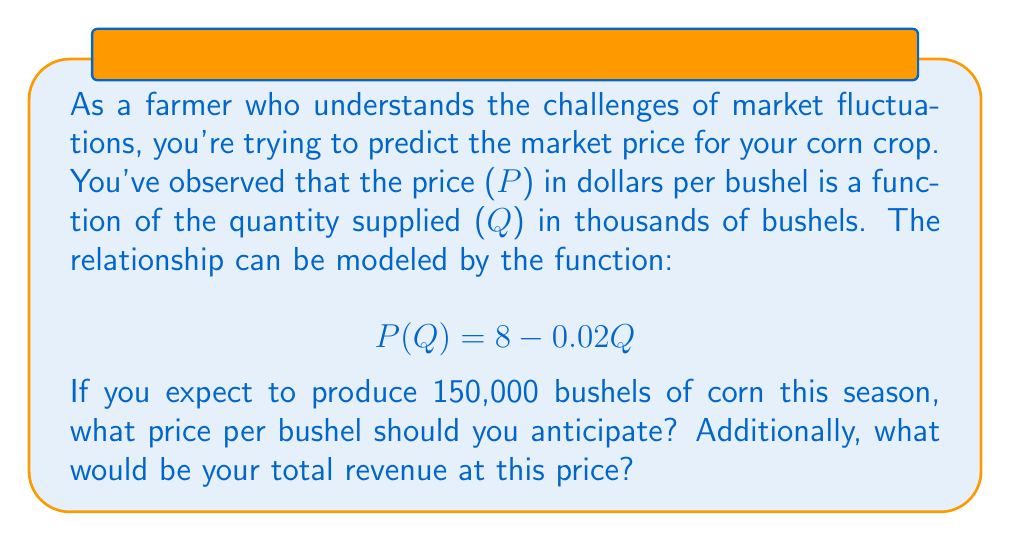Provide a solution to this math problem. To solve this problem, we'll follow these steps:

1. Determine the quantity (Q) in thousands of bushels:
   150,000 bushels = 150 thousand bushels
   So, Q = 150

2. Use the given function to calculate the price per bushel:
   $$P(Q) = 8 - 0.02Q$$
   $$P(150) = 8 - 0.02(150)$$
   $$P(150) = 8 - 3$$
   $$P(150) = 5$$

   So, the anticipated price is $5 per bushel.

3. Calculate the total revenue:
   Total Revenue = Price per bushel × Number of bushels
   $$R = 5 \times 150,000 = 750,000$$

   The total revenue would be $750,000.

This function illustrates the inverse relationship between supply and price in the market. As the quantity supplied increases, the price decreases, which is a common scenario farmers face in crop markets.
Answer: The anticipated price for corn is $5 per bushel, and the total revenue would be $750,000. 